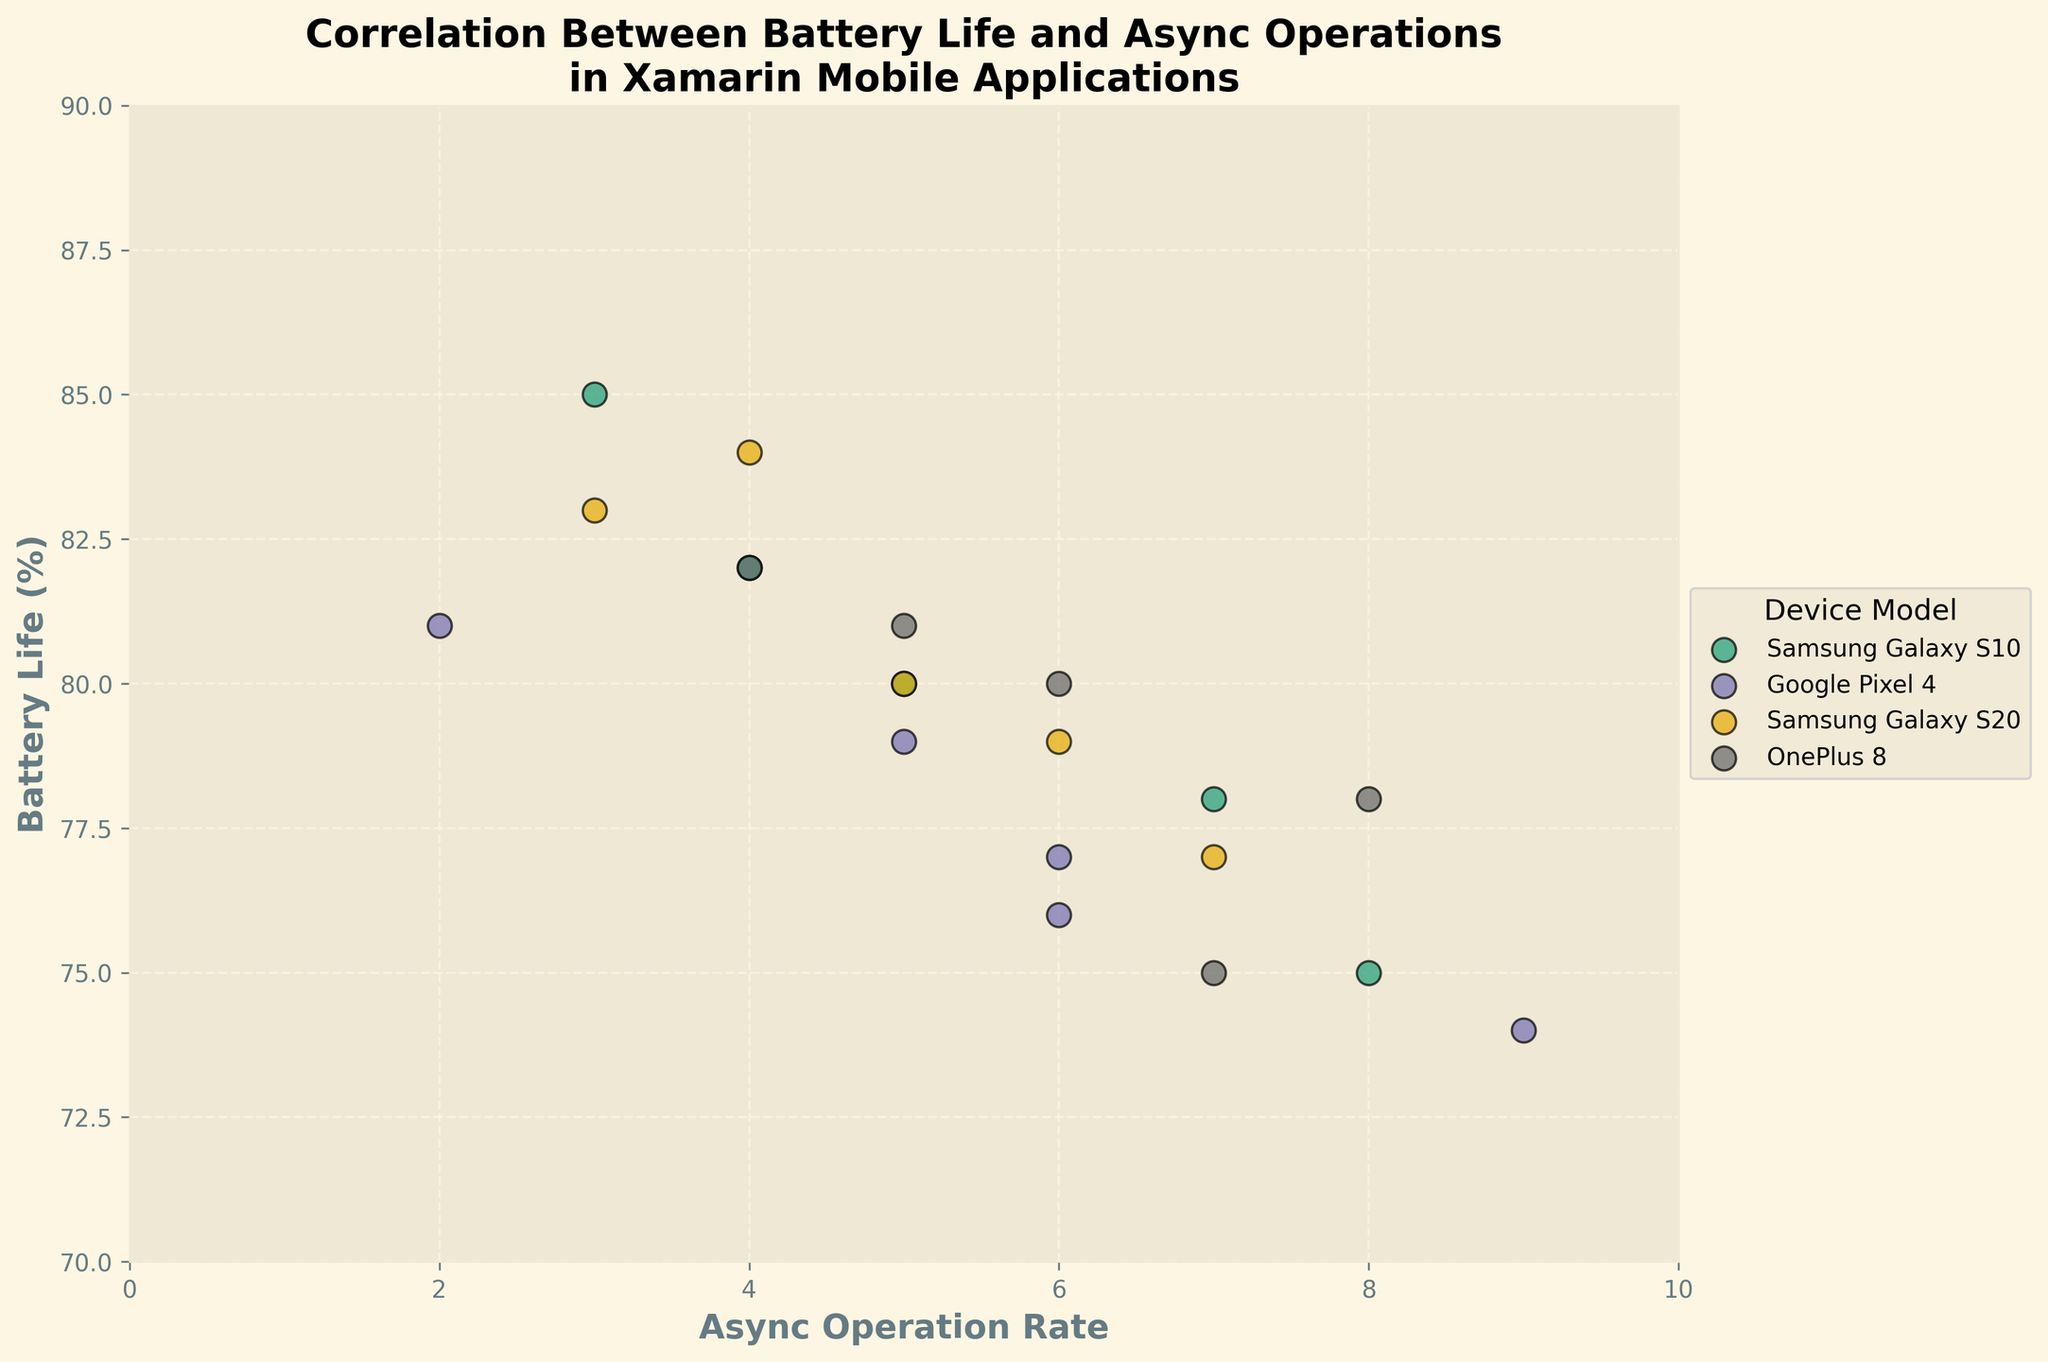What's the title of the figure? The title is typically found at the top of the figure. In this case, the title of the figure is written in a larger font to stand out.
Answer: Correlation Between Battery Life and Async Operations in Xamarin Mobile Applications What is the x-axis labeled? The label for the x-axis is usually found at the bottom of the x-axis. Here, it describes what the horizontal values represent in the figure.
Answer: Async Operation Rate What is the y-axis labeled? The label for the y-axis is typically positioned along the left side of the y-axis. It describes the vertical values.
Answer: Battery Life (%) What is the range of the x-axis? The x-axis range can be identified by looking at the minimum and maximum values along the x-axis. This figure spans from 0 to 10.
Answer: 0 to 10 What is the range of the y-axis? The y-axis range is determined by the minimum and maximum values seen along the y-axis. This figure spans from 70 to 90.
Answer: 70 to 90 How many device models are shown in the figure? The different device models are represented by varying colors and are listed in the legend to the right of the plot. Each unique item in the legend corresponds to a different device model.
Answer: 4 Which device model has the data point with the highest battery life? To find this, we look for the highest y-value (Battery Life) among the data points and identify the corresponding device model from the legend. The highest data point is above 85.
Answer: Samsung Galaxy S10 Which device model has the highest average async operation rate? Calculate the average async operation rate for each device model and compare these averages. For Samsung Galaxy S10: (5 + 7 + 3 + 8 + 4)/5 = 5.4. For Google Pixel 4: (6 + 9 + 2 + 5 + 6)/5 = 5.6. For Samsung Galaxy S20: (3 + 5 + 7 + 4 + 6)/5 = 5. For OnePlus 8: (7 + 4 + 6 + 8 + 5)/5 = 6.
Answer: OnePlus 8 Which device model appears to have a weak correlation between async operation rate and battery life? A weak correlation would mean there's no clear trend or pattern between async operation rate and battery life for the device model. By observing the scatter plot, we check which model's points appear scattered without a trend.
Answer: Samsung Galaxy S10 Are there any outliers in the data, and if so, for which device model? An outlier is a data point significantly different from others in the dataset. Find the points that look separated from their groups. There is one point at AsyncOperationRate close to 9 and BatteryLife around 74.
Answer: Google Pixel 4 